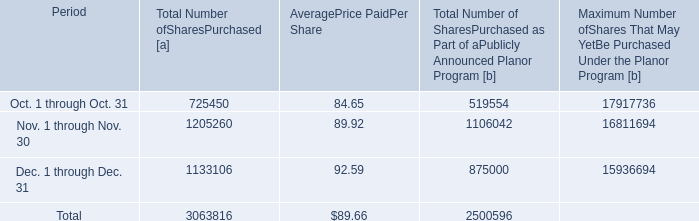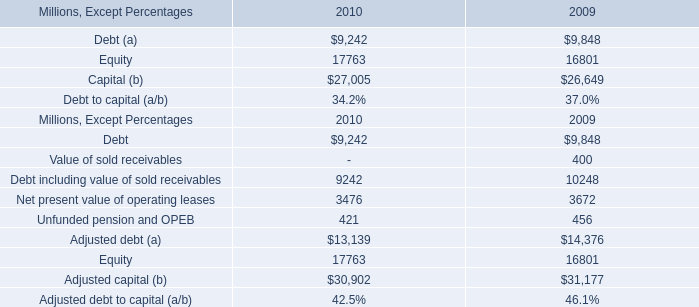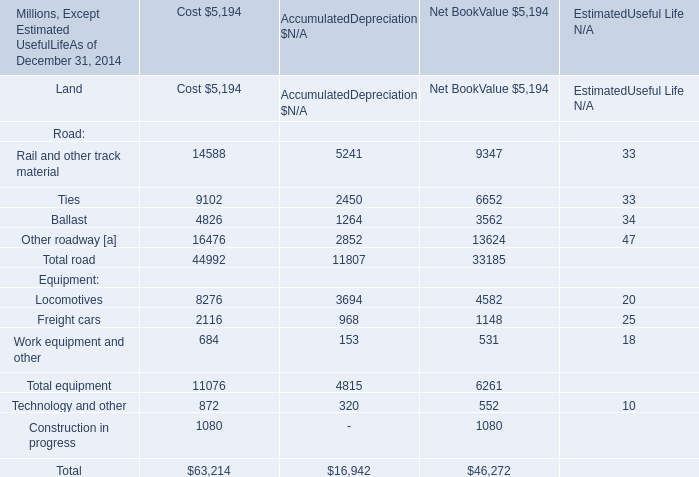What is the Net Book Value for Freight cars as of December 31,2014? (in million) 
Answer: 1148. How much is the Net Book Value for Total equipment as of December 31,2014 higher than the Net Book Value for Freight cars as of December 31,2014? (in million) 
Computations: (6261 - 1148)
Answer: 5113.0. 